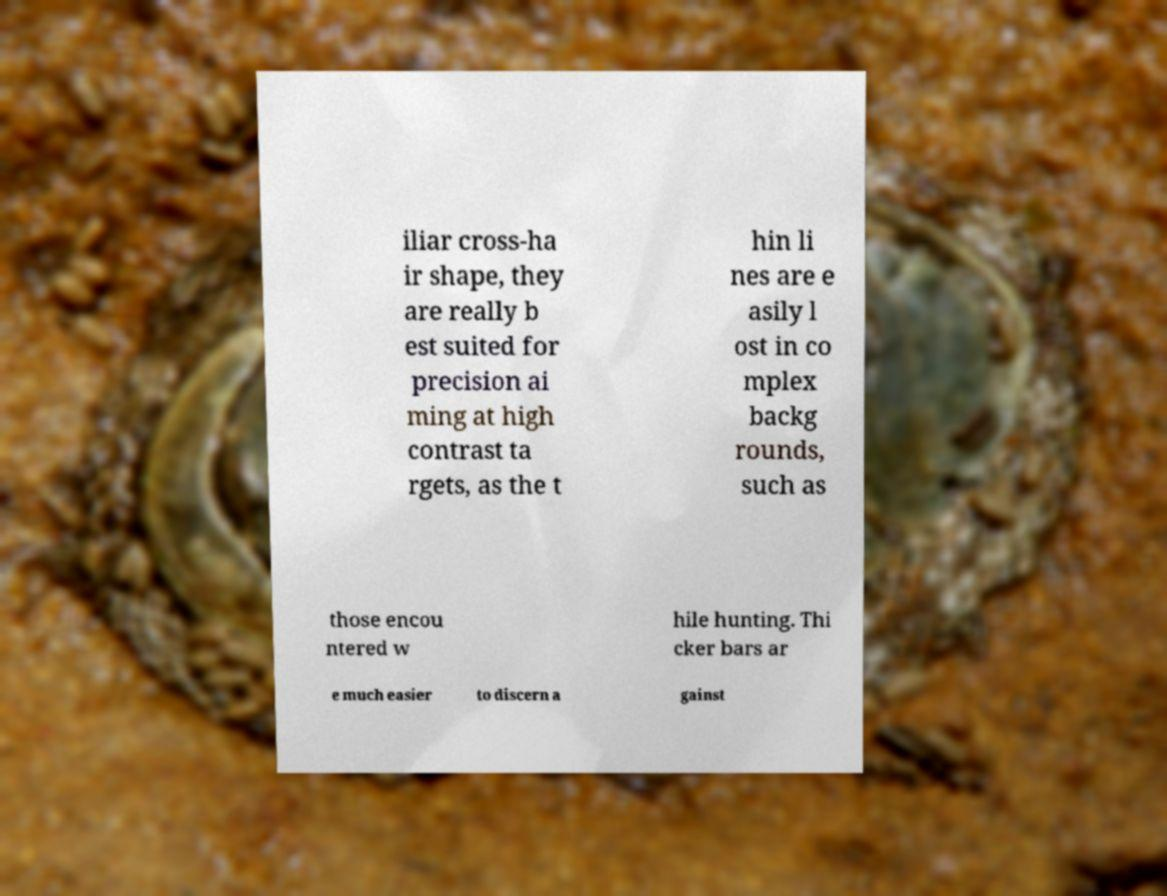I need the written content from this picture converted into text. Can you do that? iliar cross-ha ir shape, they are really b est suited for precision ai ming at high contrast ta rgets, as the t hin li nes are e asily l ost in co mplex backg rounds, such as those encou ntered w hile hunting. Thi cker bars ar e much easier to discern a gainst 